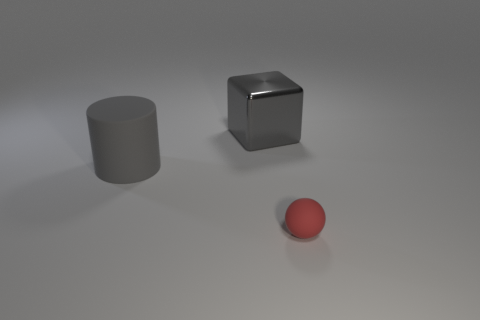Add 3 large brown metallic spheres. How many objects exist? 6 Subtract 1 balls. How many balls are left? 0 Subtract all large matte things. Subtract all large shiny things. How many objects are left? 1 Add 2 small red matte things. How many small red matte things are left? 3 Add 3 metallic things. How many metallic things exist? 4 Subtract 1 gray cubes. How many objects are left? 2 Subtract all cylinders. How many objects are left? 2 Subtract all purple spheres. Subtract all gray cylinders. How many spheres are left? 1 